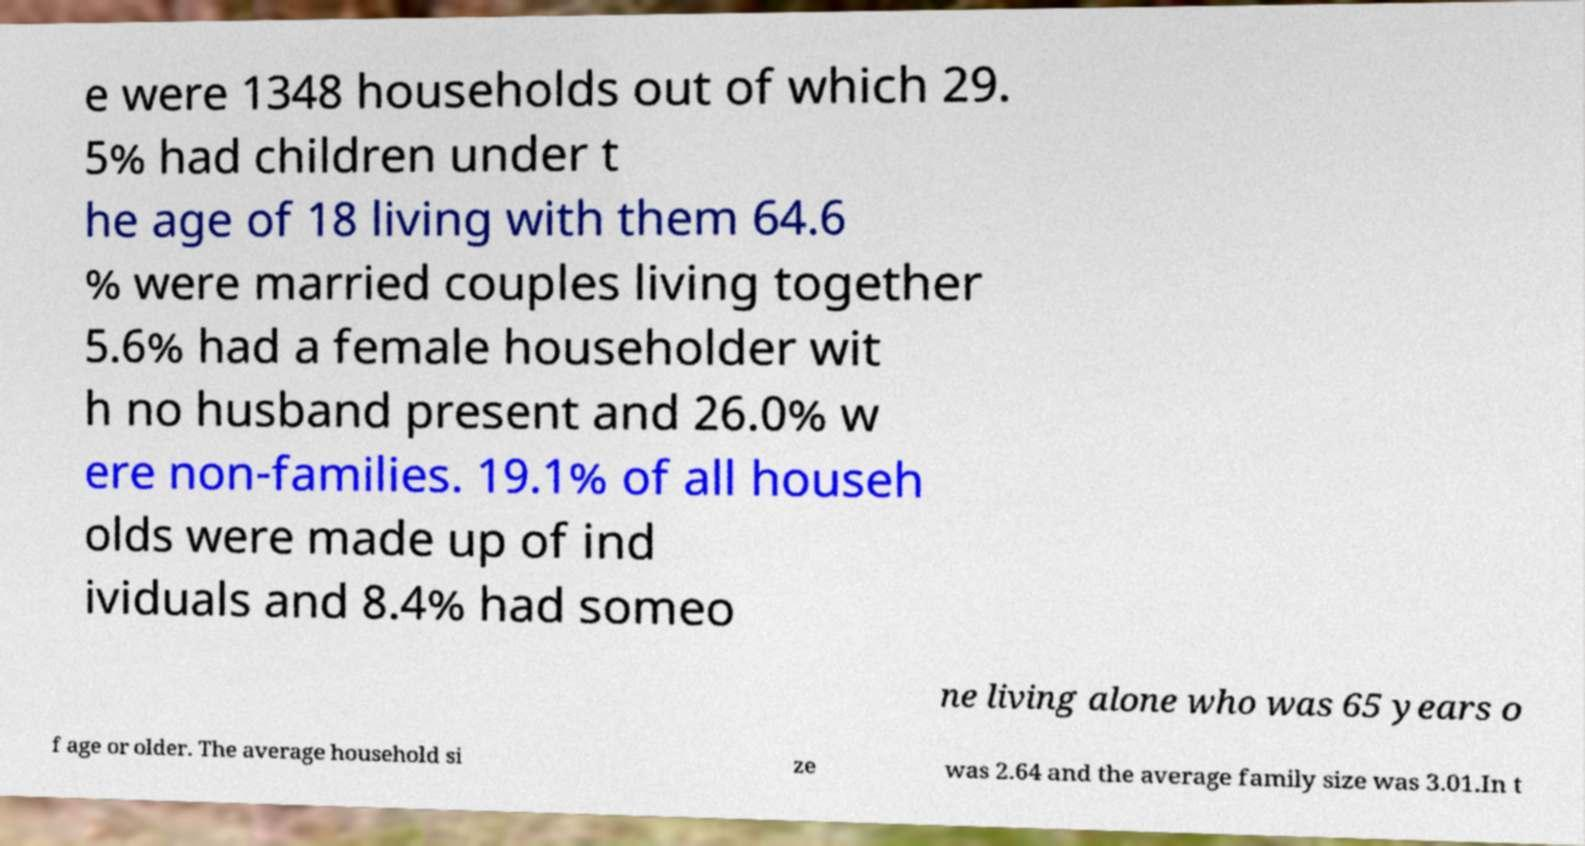I need the written content from this picture converted into text. Can you do that? e were 1348 households out of which 29. 5% had children under t he age of 18 living with them 64.6 % were married couples living together 5.6% had a female householder wit h no husband present and 26.0% w ere non-families. 19.1% of all househ olds were made up of ind ividuals and 8.4% had someo ne living alone who was 65 years o f age or older. The average household si ze was 2.64 and the average family size was 3.01.In t 